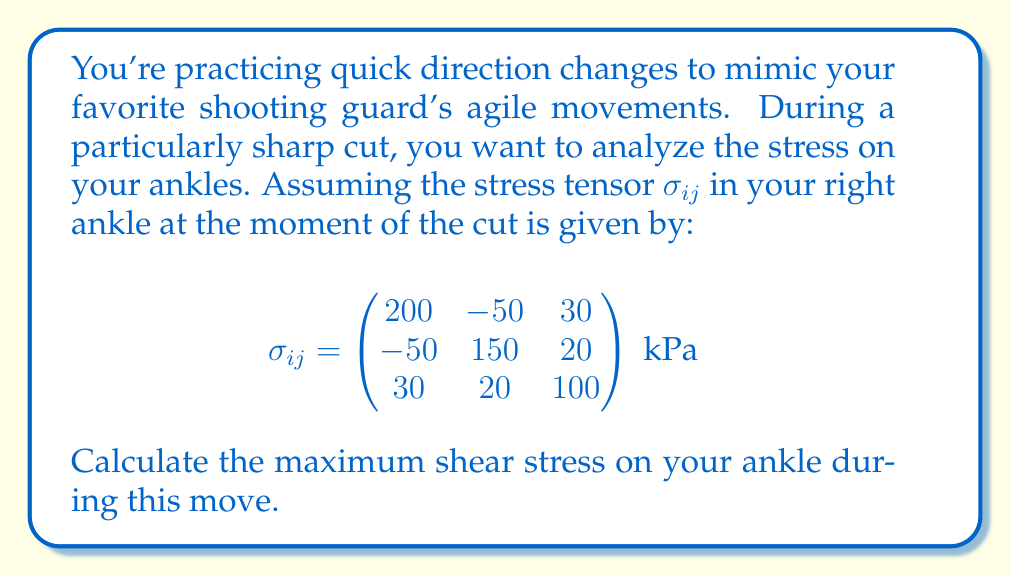Provide a solution to this math problem. To find the maximum shear stress, we need to follow these steps:

1) First, we need to find the principal stresses. These are the eigenvalues of the stress tensor.

2) The characteristic equation for the eigenvalues is:
   $$\det(\sigma_{ij} - \lambda I) = 0$$

3) Expanding this determinant:
   $$\begin{vmatrix}
   200-\lambda & -50 & 30 \\
   -50 & 150-\lambda & 20 \\
   30 & 20 & 100-\lambda
   \end{vmatrix} = 0$$

4) This leads to the cubic equation:
   $$-\lambda^3 + 450\lambda^2 - 61500\lambda + 2550000 = 0$$

5) Solving this equation (using a calculator or computer algebra system) gives the principal stresses:
   $$\lambda_1 \approx 251.7 \text{ kPa}$$
   $$\lambda_2 \approx 131.6 \text{ kPa}$$
   $$\lambda_3 \approx 66.7 \text{ kPa}$$

6) The maximum shear stress $\tau_{max}$ is given by half the difference between the maximum and minimum principal stresses:
   $$\tau_{max} = \frac{1}{2}(\lambda_{max} - \lambda_{min}) = \frac{1}{2}(\lambda_1 - \lambda_3)$$

7) Substituting the values:
   $$\tau_{max} = \frac{1}{2}(251.7 - 66.7) \approx 92.5 \text{ kPa}$$

Thus, the maximum shear stress on your ankle during this quick direction change is approximately 92.5 kPa.
Answer: 92.5 kPa 